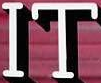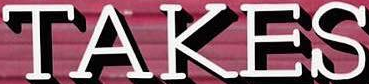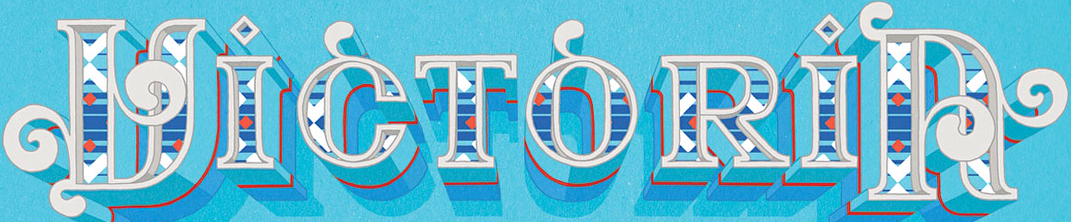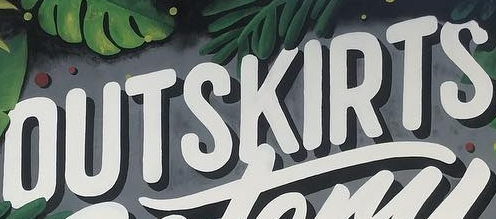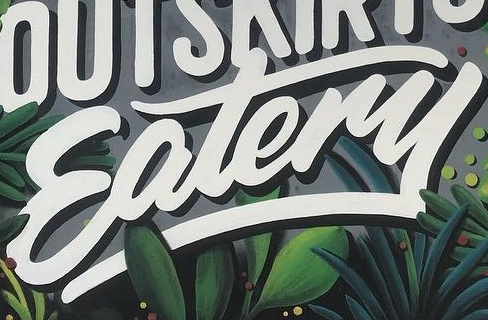What words can you see in these images in sequence, separated by a semicolon? IT; TAKES; VICTORIA; OUTSKIRTS; Eatery 